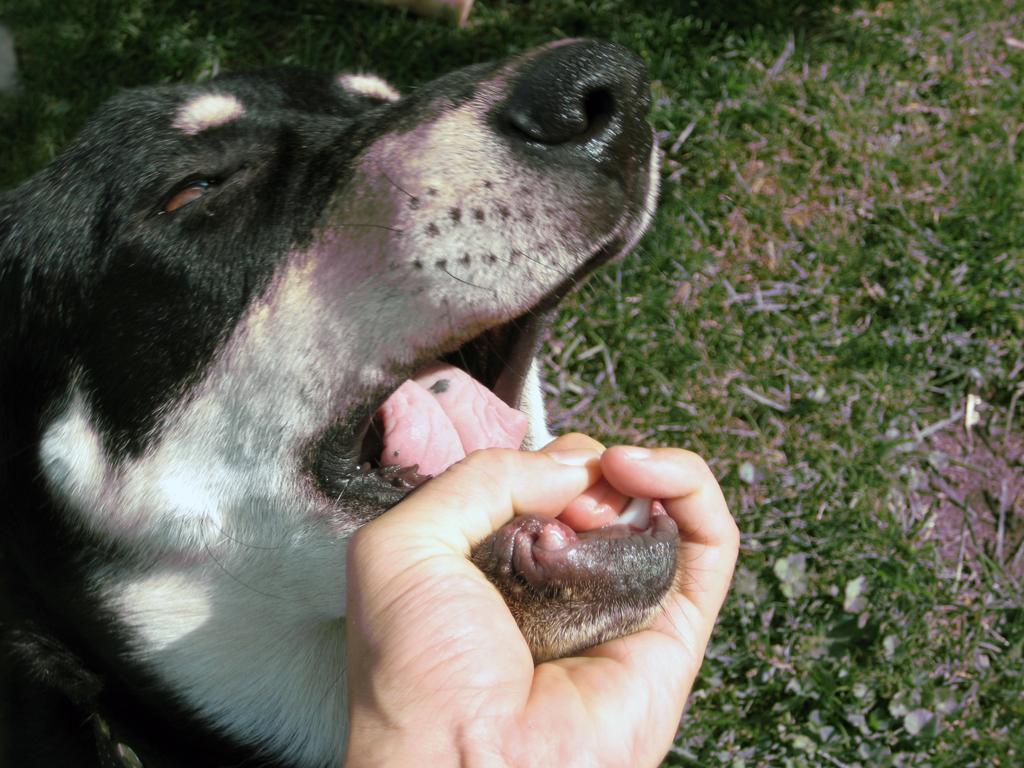Could you give a brief overview of what you see in this image? In this image we can see a dog's face, which is in black and white in color and a person is holding the mouth of a dog with a hand. 